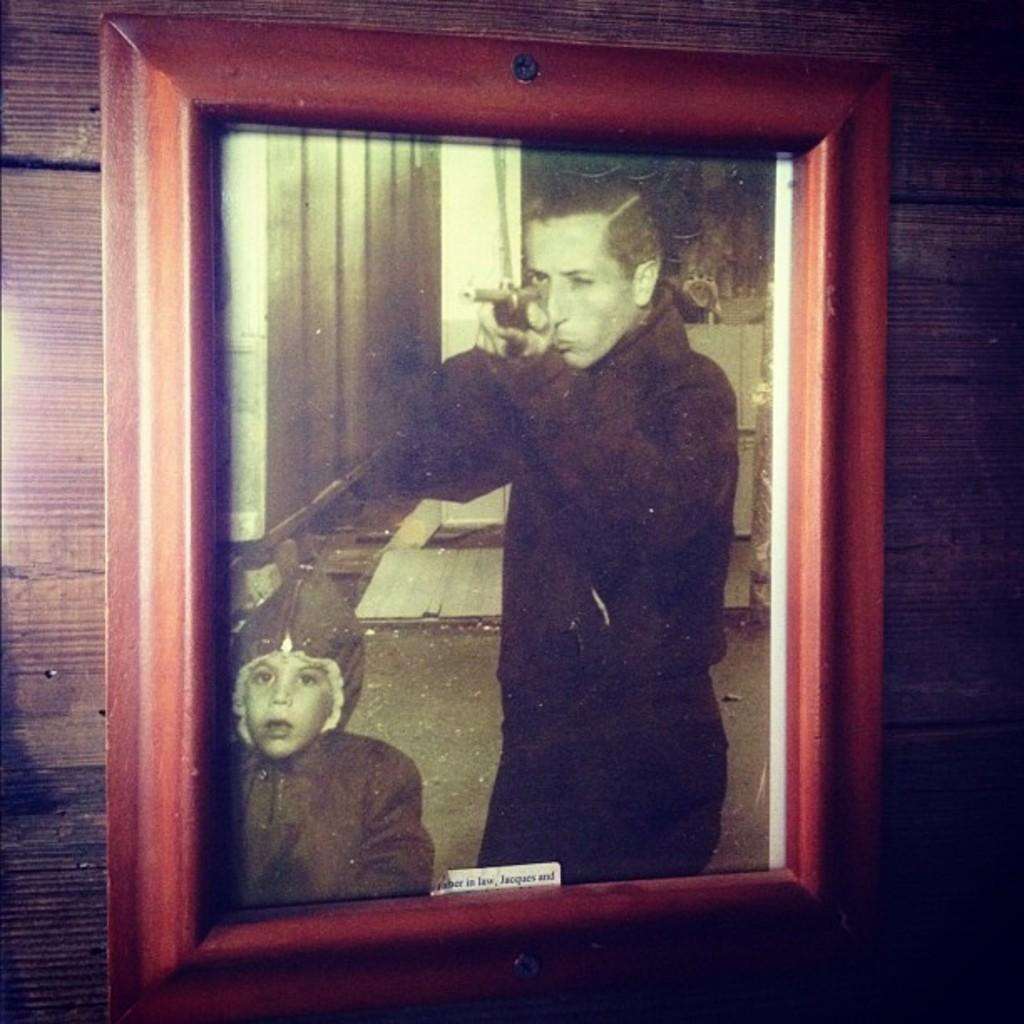What is attached to the wooden wall in the image? There is a photo frame with a sticker on a wooden wall. What is depicted in the photo frame? The photo frame contains a picture of a person holding a gun. Can you describe the presence of a child in the image? There is a kid visible in the image. What type of wine is being served at the dinner table in the image? There is no dinner table or wine present in the image; it features a photo frame with a sticker on a wooden wall and a picture of a person holding a gun. 